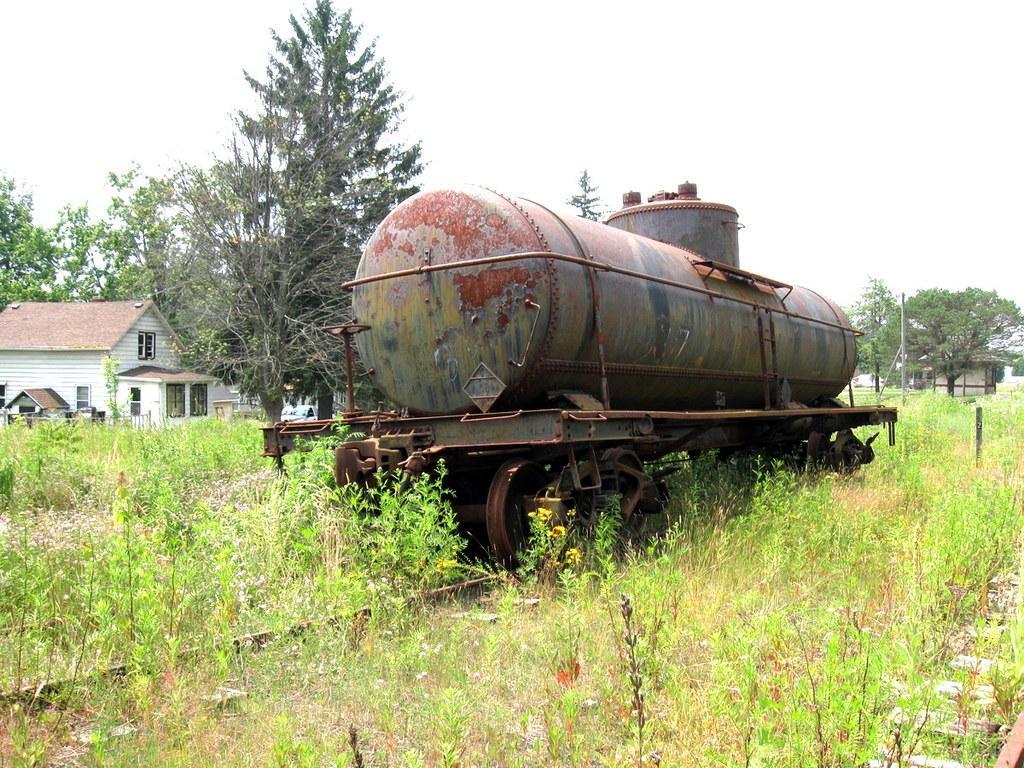Describe this image in one or two sentences. In the middle of this image, there is a tanker of a train on a railway track. At the bottom of this image, there are plants and grass. In the background, there are trees, buildings, poles and there are clouds in the sky. 